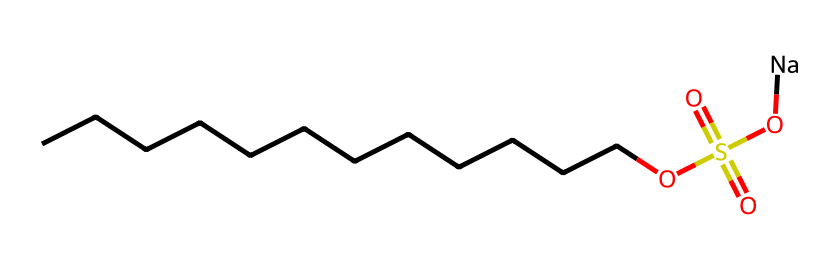How many carbon atoms does this molecule contain? By examining the SMILES representation, we count the number of carbon (C) atoms present in the linear chain represented by "CCCCCCCCCCCC", which has 12 carbon atoms.
Answer: 12 What functional groups are present in this structure? The SMILES notation shows "OS(=O)(=O)O" indicating the presence of a sulfonate group (–SO3Na) and a hydroxyl group (–OH), which are key functional groups in this surfactant.
Answer: sulfonate and hydroxyl What is the total number of oxygen atoms in this molecule? The molecule includes three oxygen atoms in the sulfonate group and one in the hydroxyl group, totaling four oxygen atoms. Thus, we count: 4 total oxygen atoms.
Answer: 4 What type of surfactant does this molecule represent? This molecule, with a large hydrocarbon chain and a polar functional group (sulfonic acid), classifies it as an anionic surfactant, which is common in detergents.
Answer: anionic What is the significance of the sodium (Na) in this compound? The presence of sodium contributes to the solubility of the surfactant in water, enhancing its ability to disperse and interact with dirt and grease in cleaning applications.
Answer: solubility What is the chain length of this detergent's hydrocarbon tail? The chain consists of 12 carbon atoms, confirming that it is a long-chain detergent, which generally improves its surfactant properties.
Answer: 12 carbon chain 